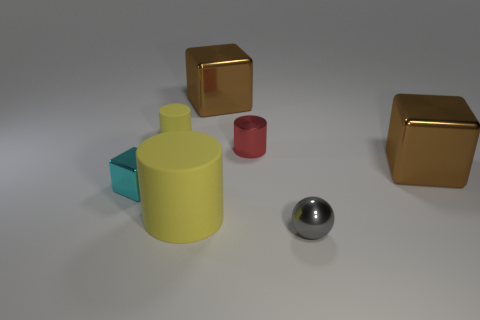Add 1 tiny cubes. How many objects exist? 8 Subtract all cubes. How many objects are left? 4 Add 7 small gray balls. How many small gray balls are left? 8 Add 3 brown things. How many brown things exist? 5 Subtract 0 brown balls. How many objects are left? 7 Subtract all large blue metal cylinders. Subtract all large blocks. How many objects are left? 5 